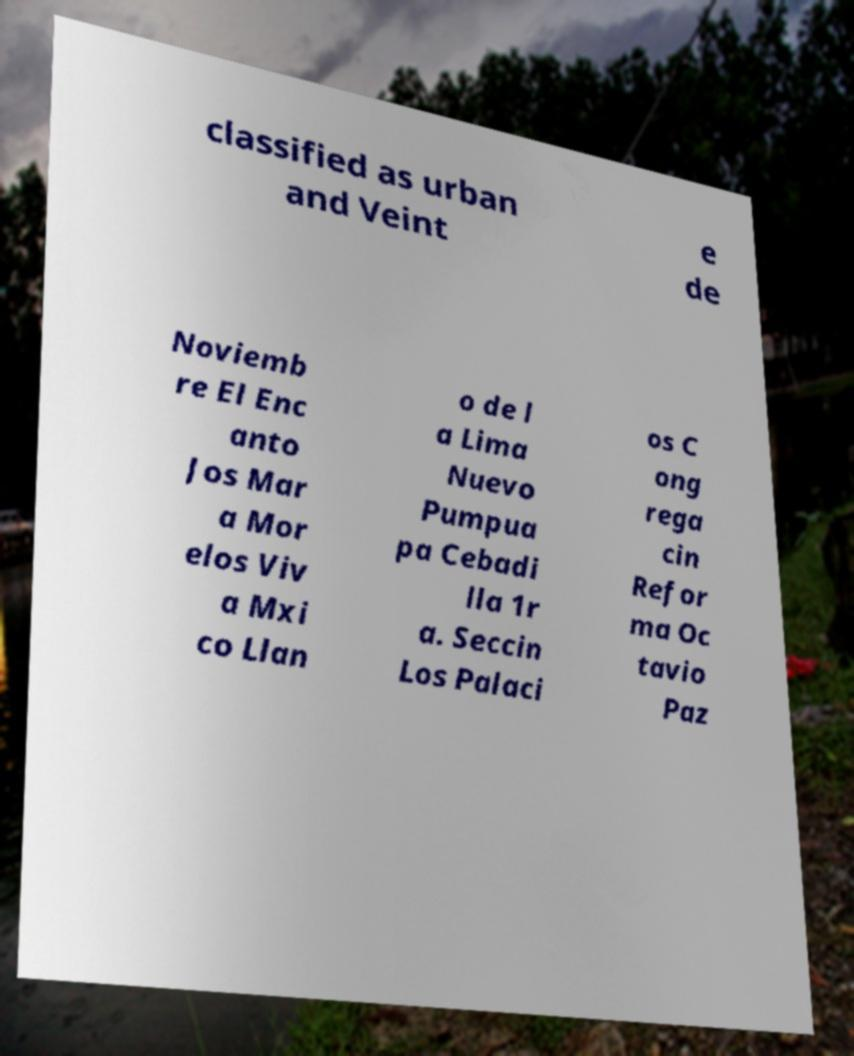Please identify and transcribe the text found in this image. classified as urban and Veint e de Noviemb re El Enc anto Jos Mar a Mor elos Viv a Mxi co Llan o de l a Lima Nuevo Pumpua pa Cebadi lla 1r a. Seccin Los Palaci os C ong rega cin Refor ma Oc tavio Paz 